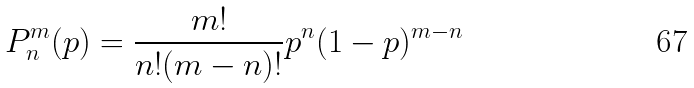<formula> <loc_0><loc_0><loc_500><loc_500>P _ { n } ^ { m } ( p ) = \frac { m ! } { n ! ( m - n ) ! } p ^ { n } ( 1 - p ) ^ { m - n }</formula> 